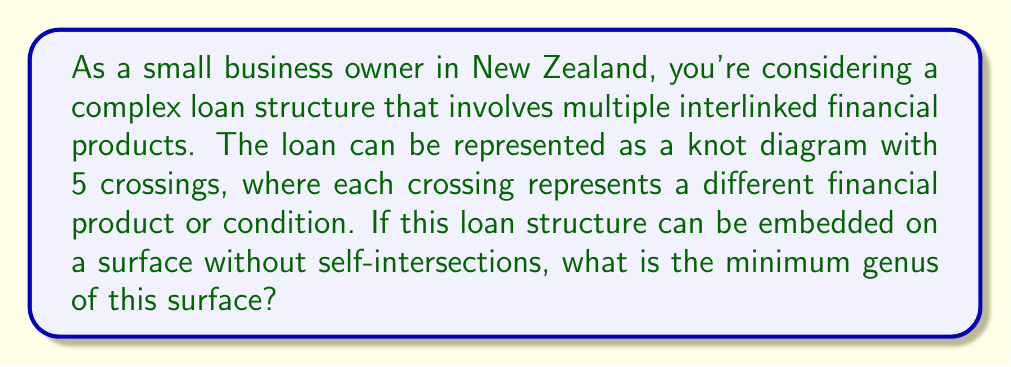Show me your answer to this math problem. To solve this problem, we'll use concepts from knot theory and the relationship between knots and surfaces:

1) First, recall that the genus of a knot $K$ is defined as the minimum genus of any orientable surface that the knot bounds.

2) For a knot diagram with $n$ crossings, we can use the following inequality:

   $$ 2g(K) \leq c(K) - 1 $$

   where $g(K)$ is the genus of the knot and $c(K)$ is the crossing number.

3) In this case, we have a knot diagram with 5 crossings, so $c(K) = 5$.

4) Substituting into the inequality:

   $$ 2g(K) \leq 5 - 1 = 4 $$

5) Solving for $g(K)$:

   $$ g(K) \leq 2 $$

6) Since the genus must be a non-negative integer, and we're asked for the minimum genus, we conclude that the genus is either 0, 1, or 2.

7) A genus of 0 would imply that this is the unknot, which is unlikely for a complex loan structure with 5 crossings.

8) A genus of 1 is possible and is the minimum integer that satisfies our inequality.

Therefore, the minimum genus of the surface on which this loan structure can be embedded without self-intersections is 1.
Answer: 1 